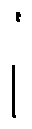<formula> <loc_0><loc_0><loc_500><loc_500>i</formula> 